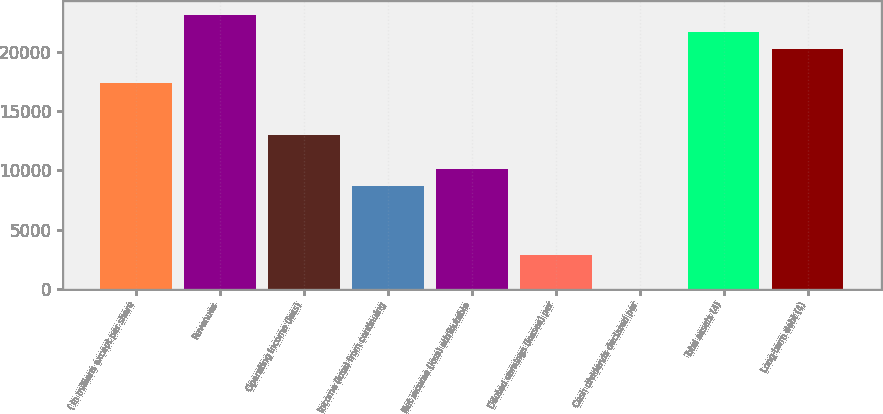Convert chart. <chart><loc_0><loc_0><loc_500><loc_500><bar_chart><fcel>( in millions except per share<fcel>Revenues<fcel>Operating income (loss)<fcel>Income (loss) from continuing<fcel>Net income (loss) attributable<fcel>Diluted earnings (losses) per<fcel>Cash dividends declared per<fcel>Total assets (4)<fcel>Long-term debt (4)<nl><fcel>17383<fcel>23177<fcel>13037.5<fcel>8691.99<fcel>10140.5<fcel>2897.97<fcel>0.95<fcel>21728.5<fcel>20280<nl></chart> 